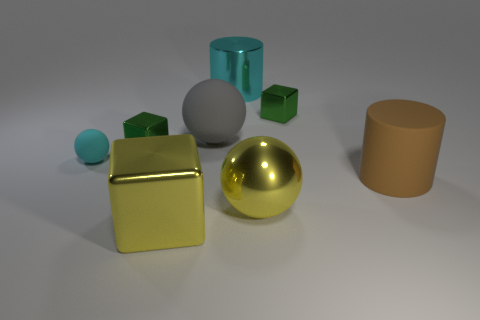What is the material of the large yellow ball?
Provide a succinct answer. Metal. How many gray objects have the same size as the cyan shiny cylinder?
Offer a very short reply. 1. There is a shiny object that is the same color as the tiny ball; what shape is it?
Offer a terse response. Cylinder. Is there a gray rubber thing that has the same shape as the big cyan metal thing?
Provide a succinct answer. No. There is a cube that is the same size as the metallic sphere; what color is it?
Provide a short and direct response. Yellow. The tiny cube that is to the left of the tiny green shiny object behind the gray rubber object is what color?
Your answer should be compact. Green. Does the cube behind the big rubber sphere have the same color as the big rubber cylinder?
Your answer should be compact. No. What is the shape of the big metal object on the left side of the big sphere that is behind the large cylinder in front of the big rubber ball?
Provide a succinct answer. Cube. There is a yellow shiny thing on the right side of the cyan cylinder; what number of large yellow shiny balls are left of it?
Offer a terse response. 0. Is the brown cylinder made of the same material as the big yellow block?
Ensure brevity in your answer.  No. 